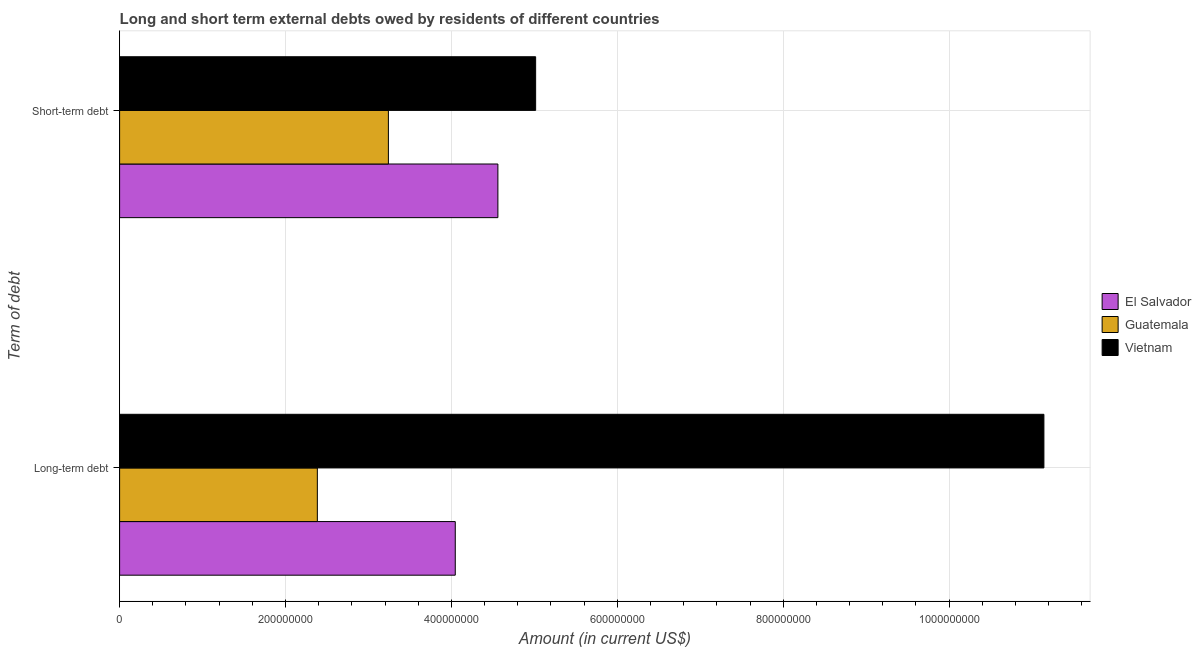How many different coloured bars are there?
Ensure brevity in your answer.  3. How many groups of bars are there?
Ensure brevity in your answer.  2. What is the label of the 1st group of bars from the top?
Your response must be concise. Short-term debt. What is the short-term debts owed by residents in Guatemala?
Your answer should be very brief. 3.24e+08. Across all countries, what is the maximum short-term debts owed by residents?
Your response must be concise. 5.02e+08. Across all countries, what is the minimum long-term debts owed by residents?
Your answer should be compact. 2.38e+08. In which country was the short-term debts owed by residents maximum?
Keep it short and to the point. Vietnam. In which country was the long-term debts owed by residents minimum?
Give a very brief answer. Guatemala. What is the total long-term debts owed by residents in the graph?
Your response must be concise. 1.76e+09. What is the difference between the short-term debts owed by residents in Vietnam and that in El Salvador?
Offer a very short reply. 4.55e+07. What is the difference between the short-term debts owed by residents in Guatemala and the long-term debts owed by residents in Vietnam?
Keep it short and to the point. -7.90e+08. What is the average long-term debts owed by residents per country?
Keep it short and to the point. 5.86e+08. What is the difference between the long-term debts owed by residents and short-term debts owed by residents in Guatemala?
Ensure brevity in your answer.  -8.56e+07. What is the ratio of the long-term debts owed by residents in Guatemala to that in El Salvador?
Offer a very short reply. 0.59. In how many countries, is the long-term debts owed by residents greater than the average long-term debts owed by residents taken over all countries?
Provide a succinct answer. 1. What does the 2nd bar from the top in Short-term debt represents?
Keep it short and to the point. Guatemala. What does the 3rd bar from the bottom in Long-term debt represents?
Provide a succinct answer. Vietnam. How many countries are there in the graph?
Provide a succinct answer. 3. Does the graph contain grids?
Keep it short and to the point. Yes. Where does the legend appear in the graph?
Make the answer very short. Center right. What is the title of the graph?
Offer a terse response. Long and short term external debts owed by residents of different countries. Does "Japan" appear as one of the legend labels in the graph?
Provide a succinct answer. No. What is the label or title of the Y-axis?
Your answer should be very brief. Term of debt. What is the Amount (in current US$) in El Salvador in Long-term debt?
Make the answer very short. 4.05e+08. What is the Amount (in current US$) of Guatemala in Long-term debt?
Your answer should be compact. 2.38e+08. What is the Amount (in current US$) in Vietnam in Long-term debt?
Offer a very short reply. 1.11e+09. What is the Amount (in current US$) of El Salvador in Short-term debt?
Make the answer very short. 4.56e+08. What is the Amount (in current US$) in Guatemala in Short-term debt?
Your answer should be very brief. 3.24e+08. What is the Amount (in current US$) in Vietnam in Short-term debt?
Offer a very short reply. 5.02e+08. Across all Term of debt, what is the maximum Amount (in current US$) in El Salvador?
Provide a short and direct response. 4.56e+08. Across all Term of debt, what is the maximum Amount (in current US$) of Guatemala?
Ensure brevity in your answer.  3.24e+08. Across all Term of debt, what is the maximum Amount (in current US$) of Vietnam?
Provide a succinct answer. 1.11e+09. Across all Term of debt, what is the minimum Amount (in current US$) in El Salvador?
Provide a short and direct response. 4.05e+08. Across all Term of debt, what is the minimum Amount (in current US$) of Guatemala?
Your answer should be very brief. 2.38e+08. Across all Term of debt, what is the minimum Amount (in current US$) in Vietnam?
Provide a short and direct response. 5.02e+08. What is the total Amount (in current US$) in El Salvador in the graph?
Ensure brevity in your answer.  8.61e+08. What is the total Amount (in current US$) in Guatemala in the graph?
Give a very brief answer. 5.62e+08. What is the total Amount (in current US$) of Vietnam in the graph?
Keep it short and to the point. 1.62e+09. What is the difference between the Amount (in current US$) of El Salvador in Long-term debt and that in Short-term debt?
Your response must be concise. -5.14e+07. What is the difference between the Amount (in current US$) of Guatemala in Long-term debt and that in Short-term debt?
Make the answer very short. -8.56e+07. What is the difference between the Amount (in current US$) in Vietnam in Long-term debt and that in Short-term debt?
Provide a short and direct response. 6.13e+08. What is the difference between the Amount (in current US$) in El Salvador in Long-term debt and the Amount (in current US$) in Guatemala in Short-term debt?
Ensure brevity in your answer.  8.06e+07. What is the difference between the Amount (in current US$) of El Salvador in Long-term debt and the Amount (in current US$) of Vietnam in Short-term debt?
Ensure brevity in your answer.  -9.69e+07. What is the difference between the Amount (in current US$) in Guatemala in Long-term debt and the Amount (in current US$) in Vietnam in Short-term debt?
Keep it short and to the point. -2.63e+08. What is the average Amount (in current US$) in El Salvador per Term of debt?
Give a very brief answer. 4.30e+08. What is the average Amount (in current US$) of Guatemala per Term of debt?
Provide a succinct answer. 2.81e+08. What is the average Amount (in current US$) of Vietnam per Term of debt?
Make the answer very short. 8.08e+08. What is the difference between the Amount (in current US$) of El Salvador and Amount (in current US$) of Guatemala in Long-term debt?
Make the answer very short. 1.66e+08. What is the difference between the Amount (in current US$) of El Salvador and Amount (in current US$) of Vietnam in Long-term debt?
Offer a very short reply. -7.10e+08. What is the difference between the Amount (in current US$) of Guatemala and Amount (in current US$) of Vietnam in Long-term debt?
Provide a succinct answer. -8.76e+08. What is the difference between the Amount (in current US$) of El Salvador and Amount (in current US$) of Guatemala in Short-term debt?
Give a very brief answer. 1.32e+08. What is the difference between the Amount (in current US$) of El Salvador and Amount (in current US$) of Vietnam in Short-term debt?
Provide a short and direct response. -4.55e+07. What is the difference between the Amount (in current US$) of Guatemala and Amount (in current US$) of Vietnam in Short-term debt?
Provide a succinct answer. -1.78e+08. What is the ratio of the Amount (in current US$) in El Salvador in Long-term debt to that in Short-term debt?
Keep it short and to the point. 0.89. What is the ratio of the Amount (in current US$) of Guatemala in Long-term debt to that in Short-term debt?
Make the answer very short. 0.74. What is the ratio of the Amount (in current US$) of Vietnam in Long-term debt to that in Short-term debt?
Provide a short and direct response. 2.22. What is the difference between the highest and the second highest Amount (in current US$) of El Salvador?
Your response must be concise. 5.14e+07. What is the difference between the highest and the second highest Amount (in current US$) in Guatemala?
Give a very brief answer. 8.56e+07. What is the difference between the highest and the second highest Amount (in current US$) of Vietnam?
Your answer should be very brief. 6.13e+08. What is the difference between the highest and the lowest Amount (in current US$) in El Salvador?
Give a very brief answer. 5.14e+07. What is the difference between the highest and the lowest Amount (in current US$) of Guatemala?
Offer a terse response. 8.56e+07. What is the difference between the highest and the lowest Amount (in current US$) of Vietnam?
Give a very brief answer. 6.13e+08. 